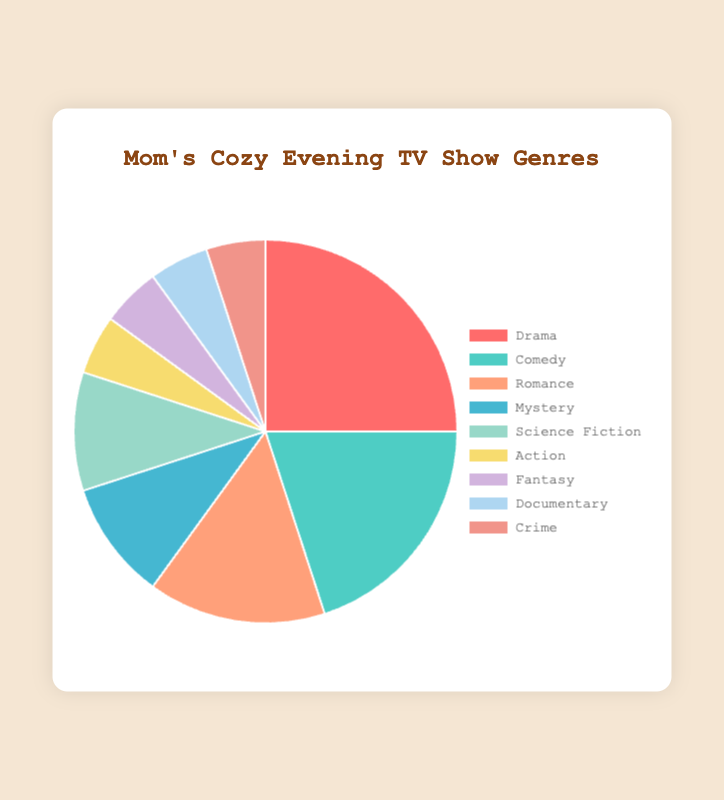Which genre has the largest percentage of my favorite TV shows? By observing the figure, the Drama section visually takes up the largest portion of the pie chart.
Answer: Drama Which two genres tie in percentage and what is their value? The chart shows that Action, Fantasy, Documentary, and Crime all share the same percentage slice of 5%.
Answer: Action, Fantasy, Documentary, and Crime, 5% What is the combined percentage of Drama and Comedy genres? The Drama genre is 25%, and Comedy is 20%. Adding these values together gives 25% + 20% = 45%.
Answer: 45% Which genre is less prevalent, Romance or Mystery? The pie chart shows that Romance has 15% and Mystery has 10%. Since 10% is less than 15%, Mystery is less prevalent.
Answer: Mystery What is the difference in percentage between Science Fiction and Action genres? The percentage for Science Fiction is 10%, and for Action, it is 5%. The difference is 10% - 5% = 5%.
Answer: 5% Which genre has the same percentage as Documentary and what color represents it in the pie chart? Both Fantasy and Crime have the same percentage as Documentary, which is 5%, and Fantasy is represented by a lavender-like color.
Answer: Fantasy, lavender-like Out of all the genres listed, how many genres have a percentage greater than or equal to 10%? The genres with 10% or more are Drama, Comedy, Romance, Mystery, and Science Fiction. By counting them: 1 (Drama) + 1 (Comedy) + 1 (Romance) + 1 (Mystery) + 1 (Science Fiction) = 5 genres.
Answer: 5 What color represents the Mystery genre and what percentage does it hold? The Mystery genre holds 10% of the total and is represented by a sky-blue color in the pie chart.
Answer: sky-blue, 10% If Drama and Comedy were combined into one genre, what would be its new percentage and how would its share compare with the other genres? Drama is 25% and Comedy is 20%. Combining these gives 25% + 20% = 45%. This new genre would have the largest share compared to any other single genre.
Answer: 45%, largest What percentage of the chart is made up by the least common genres (those that individually have 5% each)? The least common genres are Action, Fantasy, Documentary, and Crime, all having 5%. Adding these together: 5% + 5% + 5% + 5% = 20%.
Answer: 20% 